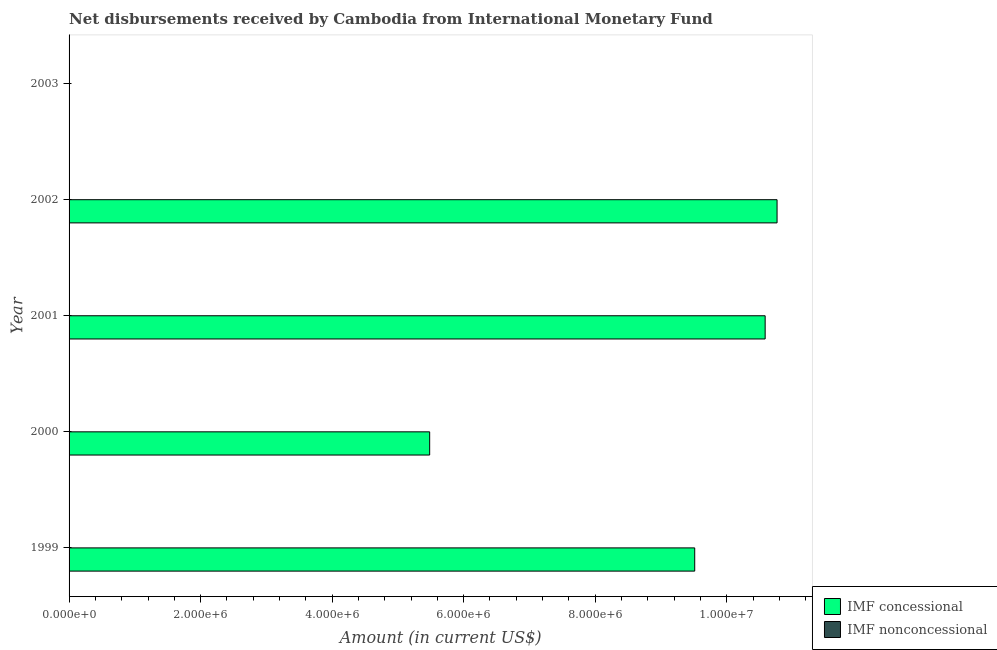How many different coloured bars are there?
Offer a very short reply. 1. Are the number of bars per tick equal to the number of legend labels?
Give a very brief answer. No. Are the number of bars on each tick of the Y-axis equal?
Your response must be concise. No. In how many cases, is the number of bars for a given year not equal to the number of legend labels?
Your response must be concise. 5. What is the net non concessional disbursements from imf in 2000?
Make the answer very short. 0. Across all years, what is the maximum net concessional disbursements from imf?
Your answer should be compact. 1.08e+07. In which year was the net concessional disbursements from imf maximum?
Your response must be concise. 2002. What is the total net concessional disbursements from imf in the graph?
Give a very brief answer. 3.63e+07. What is the difference between the net concessional disbursements from imf in 2000 and that in 2001?
Keep it short and to the point. -5.10e+06. What is the difference between the net concessional disbursements from imf in 1999 and the net non concessional disbursements from imf in 2002?
Provide a succinct answer. 9.51e+06. What is the average net non concessional disbursements from imf per year?
Your answer should be very brief. 0. In how many years, is the net concessional disbursements from imf greater than 8000000 US$?
Your response must be concise. 3. Is the net concessional disbursements from imf in 2001 less than that in 2002?
Make the answer very short. Yes. What is the difference between the highest and the second highest net concessional disbursements from imf?
Offer a terse response. 1.81e+05. What is the difference between the highest and the lowest net concessional disbursements from imf?
Ensure brevity in your answer.  1.08e+07. In how many years, is the net concessional disbursements from imf greater than the average net concessional disbursements from imf taken over all years?
Provide a short and direct response. 3. Is the sum of the net concessional disbursements from imf in 2000 and 2002 greater than the maximum net non concessional disbursements from imf across all years?
Offer a terse response. Yes. How many bars are there?
Your answer should be very brief. 4. Are all the bars in the graph horizontal?
Provide a short and direct response. Yes. What is the difference between two consecutive major ticks on the X-axis?
Offer a terse response. 2.00e+06. Are the values on the major ticks of X-axis written in scientific E-notation?
Provide a succinct answer. Yes. Does the graph contain any zero values?
Your response must be concise. Yes. How many legend labels are there?
Your answer should be compact. 2. How are the legend labels stacked?
Your response must be concise. Vertical. What is the title of the graph?
Make the answer very short. Net disbursements received by Cambodia from International Monetary Fund. Does "Young" appear as one of the legend labels in the graph?
Your answer should be compact. No. What is the Amount (in current US$) in IMF concessional in 1999?
Offer a very short reply. 9.51e+06. What is the Amount (in current US$) in IMF nonconcessional in 1999?
Your answer should be very brief. 0. What is the Amount (in current US$) in IMF concessional in 2000?
Provide a short and direct response. 5.48e+06. What is the Amount (in current US$) of IMF nonconcessional in 2000?
Provide a succinct answer. 0. What is the Amount (in current US$) in IMF concessional in 2001?
Your response must be concise. 1.06e+07. What is the Amount (in current US$) in IMF nonconcessional in 2001?
Keep it short and to the point. 0. What is the Amount (in current US$) in IMF concessional in 2002?
Your response must be concise. 1.08e+07. What is the Amount (in current US$) of IMF nonconcessional in 2002?
Ensure brevity in your answer.  0. What is the Amount (in current US$) in IMF concessional in 2003?
Ensure brevity in your answer.  0. Across all years, what is the maximum Amount (in current US$) in IMF concessional?
Give a very brief answer. 1.08e+07. What is the total Amount (in current US$) of IMF concessional in the graph?
Your answer should be very brief. 3.63e+07. What is the difference between the Amount (in current US$) of IMF concessional in 1999 and that in 2000?
Offer a terse response. 4.03e+06. What is the difference between the Amount (in current US$) of IMF concessional in 1999 and that in 2001?
Your answer should be compact. -1.07e+06. What is the difference between the Amount (in current US$) in IMF concessional in 1999 and that in 2002?
Ensure brevity in your answer.  -1.25e+06. What is the difference between the Amount (in current US$) in IMF concessional in 2000 and that in 2001?
Your response must be concise. -5.10e+06. What is the difference between the Amount (in current US$) in IMF concessional in 2000 and that in 2002?
Your answer should be compact. -5.28e+06. What is the difference between the Amount (in current US$) in IMF concessional in 2001 and that in 2002?
Offer a terse response. -1.81e+05. What is the average Amount (in current US$) of IMF concessional per year?
Give a very brief answer. 7.27e+06. What is the ratio of the Amount (in current US$) in IMF concessional in 1999 to that in 2000?
Keep it short and to the point. 1.74. What is the ratio of the Amount (in current US$) in IMF concessional in 1999 to that in 2001?
Make the answer very short. 0.9. What is the ratio of the Amount (in current US$) of IMF concessional in 1999 to that in 2002?
Your answer should be very brief. 0.88. What is the ratio of the Amount (in current US$) in IMF concessional in 2000 to that in 2001?
Give a very brief answer. 0.52. What is the ratio of the Amount (in current US$) of IMF concessional in 2000 to that in 2002?
Offer a terse response. 0.51. What is the ratio of the Amount (in current US$) of IMF concessional in 2001 to that in 2002?
Your answer should be compact. 0.98. What is the difference between the highest and the second highest Amount (in current US$) of IMF concessional?
Offer a very short reply. 1.81e+05. What is the difference between the highest and the lowest Amount (in current US$) of IMF concessional?
Your response must be concise. 1.08e+07. 